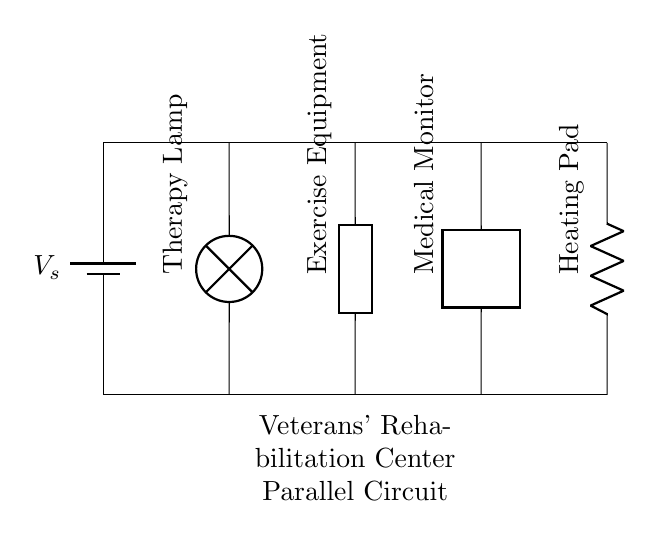What is the voltage source in this circuit? The voltage source is labeled as 'V_s', which represents the supplied voltage for the circuit. It's located at the top left of the diagram, connected to the main lines.
Answer: V_s How many devices are connected in parallel? The circuit shows a total of four devices connected in parallel to the main lines, as indicated by the separate connections from the top line to each device below.
Answer: Four What type of device is represented by 'lamp'? The 'lamp' in the circuit diagram represents a therapy lamp, which is specifically used in a rehabilitation setting to provide light for therapy purposes.
Answer: Therapy Lamp Which device can be adjusted for intensity? The 'lamp' typically allows for the adjustment of light intensity, facilitating different treatment settings during therapy sessions for veterans.
Answer: Therapy Lamp What happens if one device fails in this parallel circuit? In a parallel circuit, if one device fails, it does not affect the operation of the other devices, as each one is independently connected to the power source, maintaining functionality for the remaining devices.
Answer: Other devices continue to operate What is the main advantage of using a parallel circuit in a rehabilitation center? A parallel circuit allows for independent operation of multiple devices, ensuring that failure or removal of one device does not disrupt the use of others, which is crucial in a rehabilitation setting where multiple therapies may be administered concurrently.
Answer: Independent operation What type of circuit is depicted in this diagram? This is a parallel circuit, characterized by the fact that all devices are connected across the same voltage supply, allowing each device to operate independently.
Answer: Parallel 